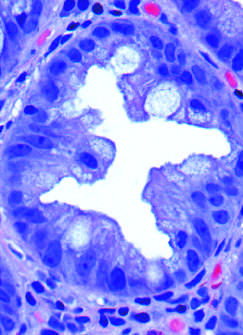what are cut in cross-section?
Answer the question using a single word or phrase. Glands 